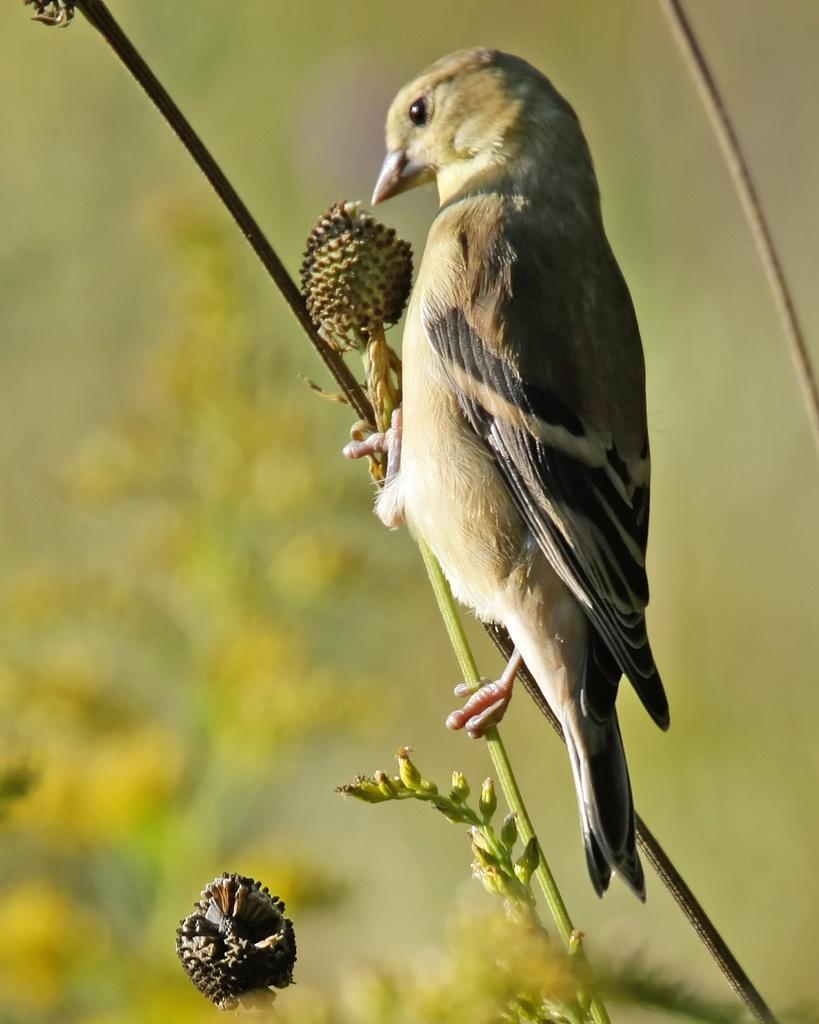Can you describe this image briefly? In the picture I can see a bird is sitting on a stem of a plant. The background of the image is blurred. 